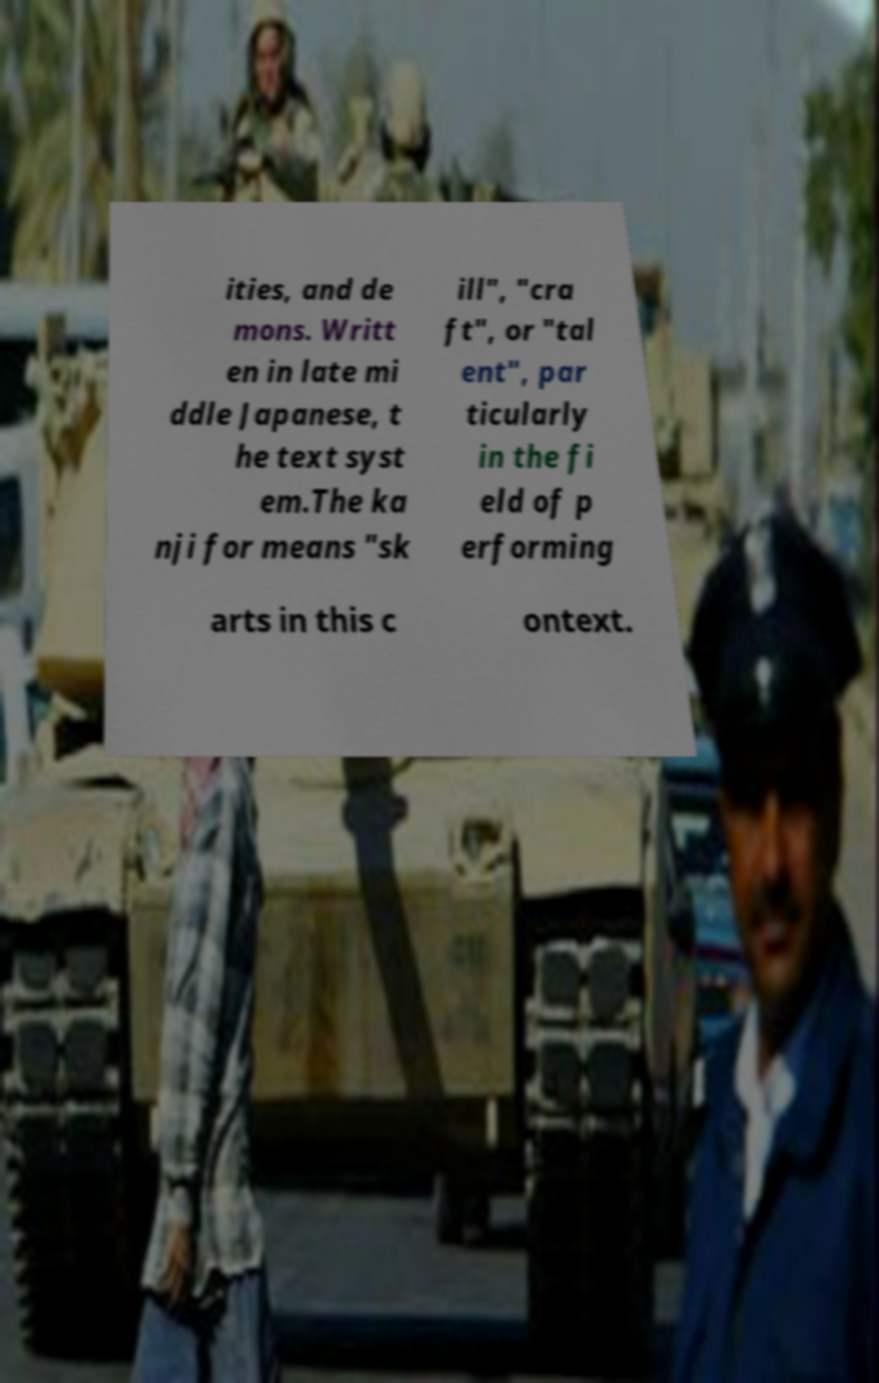Could you extract and type out the text from this image? ities, and de mons. Writt en in late mi ddle Japanese, t he text syst em.The ka nji for means "sk ill", "cra ft", or "tal ent", par ticularly in the fi eld of p erforming arts in this c ontext. 